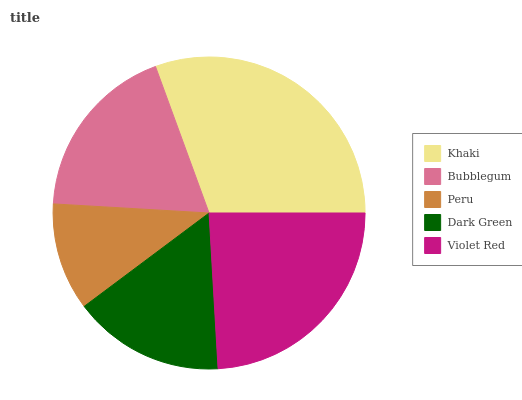Is Peru the minimum?
Answer yes or no. Yes. Is Khaki the maximum?
Answer yes or no. Yes. Is Bubblegum the minimum?
Answer yes or no. No. Is Bubblegum the maximum?
Answer yes or no. No. Is Khaki greater than Bubblegum?
Answer yes or no. Yes. Is Bubblegum less than Khaki?
Answer yes or no. Yes. Is Bubblegum greater than Khaki?
Answer yes or no. No. Is Khaki less than Bubblegum?
Answer yes or no. No. Is Bubblegum the high median?
Answer yes or no. Yes. Is Bubblegum the low median?
Answer yes or no. Yes. Is Khaki the high median?
Answer yes or no. No. Is Khaki the low median?
Answer yes or no. No. 